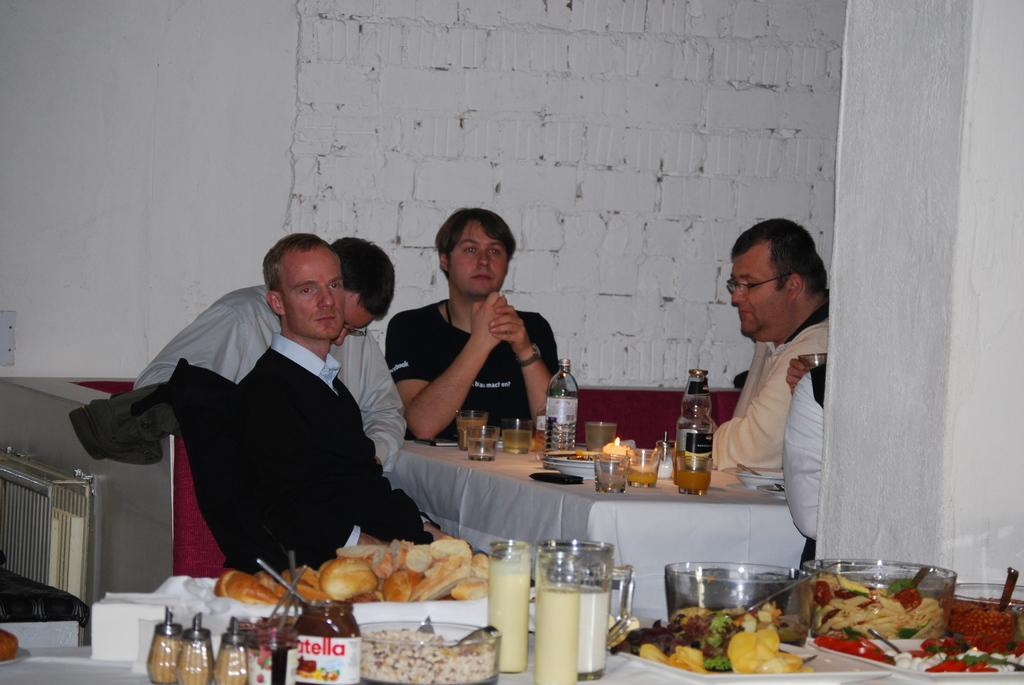Provide a one-sentence caption for the provided image. A man with a black t-shirt with the words "macht en" sits at a table. 